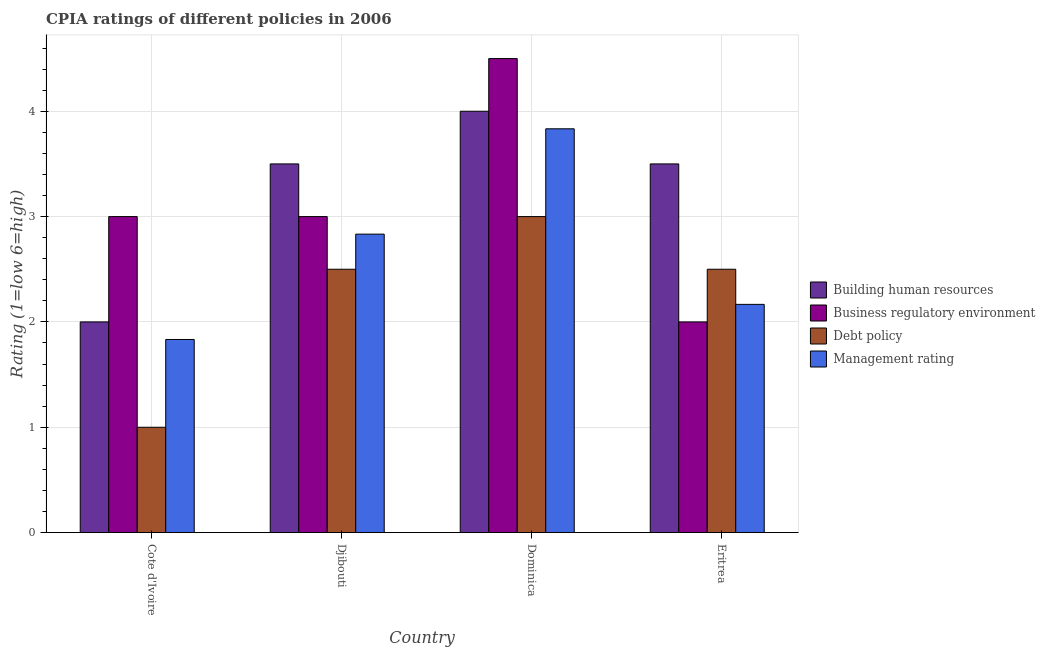How many bars are there on the 1st tick from the right?
Your answer should be compact. 4. What is the label of the 4th group of bars from the left?
Offer a terse response. Eritrea. What is the cpia rating of management in Dominica?
Give a very brief answer. 3.83. Across all countries, what is the maximum cpia rating of debt policy?
Keep it short and to the point. 3. Across all countries, what is the minimum cpia rating of building human resources?
Ensure brevity in your answer.  2. In which country was the cpia rating of building human resources maximum?
Your answer should be very brief. Dominica. In which country was the cpia rating of debt policy minimum?
Give a very brief answer. Cote d'Ivoire. What is the total cpia rating of debt policy in the graph?
Your answer should be very brief. 9. What is the difference between the cpia rating of building human resources in Djibouti and that in Dominica?
Make the answer very short. -0.5. What is the difference between the cpia rating of business regulatory environment in Cote d'Ivoire and the cpia rating of debt policy in Eritrea?
Provide a short and direct response. 0.5. What is the average cpia rating of building human resources per country?
Offer a terse response. 3.25. What is the difference between the cpia rating of business regulatory environment and cpia rating of management in Dominica?
Provide a short and direct response. 0.67. What is the ratio of the cpia rating of debt policy in Dominica to that in Eritrea?
Provide a succinct answer. 1.2. What is the difference between the highest and the second highest cpia rating of debt policy?
Offer a terse response. 0.5. What is the difference between the highest and the lowest cpia rating of debt policy?
Provide a short and direct response. 2. Is the sum of the cpia rating of building human resources in Djibouti and Dominica greater than the maximum cpia rating of debt policy across all countries?
Ensure brevity in your answer.  Yes. What does the 3rd bar from the left in Djibouti represents?
Provide a short and direct response. Debt policy. What does the 4th bar from the right in Dominica represents?
Offer a terse response. Building human resources. Is it the case that in every country, the sum of the cpia rating of building human resources and cpia rating of business regulatory environment is greater than the cpia rating of debt policy?
Keep it short and to the point. Yes. How many bars are there?
Your response must be concise. 16. Are all the bars in the graph horizontal?
Your answer should be very brief. No. Are the values on the major ticks of Y-axis written in scientific E-notation?
Make the answer very short. No. Does the graph contain any zero values?
Offer a very short reply. No. Where does the legend appear in the graph?
Provide a succinct answer. Center right. What is the title of the graph?
Your answer should be compact. CPIA ratings of different policies in 2006. Does "International Monetary Fund" appear as one of the legend labels in the graph?
Offer a very short reply. No. What is the label or title of the X-axis?
Offer a terse response. Country. What is the Rating (1=low 6=high) in Building human resources in Cote d'Ivoire?
Ensure brevity in your answer.  2. What is the Rating (1=low 6=high) in Business regulatory environment in Cote d'Ivoire?
Make the answer very short. 3. What is the Rating (1=low 6=high) of Debt policy in Cote d'Ivoire?
Offer a very short reply. 1. What is the Rating (1=low 6=high) of Management rating in Cote d'Ivoire?
Make the answer very short. 1.83. What is the Rating (1=low 6=high) in Building human resources in Djibouti?
Provide a succinct answer. 3.5. What is the Rating (1=low 6=high) in Management rating in Djibouti?
Provide a short and direct response. 2.83. What is the Rating (1=low 6=high) in Management rating in Dominica?
Make the answer very short. 3.83. What is the Rating (1=low 6=high) of Building human resources in Eritrea?
Give a very brief answer. 3.5. What is the Rating (1=low 6=high) in Debt policy in Eritrea?
Provide a succinct answer. 2.5. What is the Rating (1=low 6=high) of Management rating in Eritrea?
Keep it short and to the point. 2.17. Across all countries, what is the maximum Rating (1=low 6=high) in Business regulatory environment?
Keep it short and to the point. 4.5. Across all countries, what is the maximum Rating (1=low 6=high) in Management rating?
Offer a very short reply. 3.83. Across all countries, what is the minimum Rating (1=low 6=high) in Debt policy?
Your response must be concise. 1. Across all countries, what is the minimum Rating (1=low 6=high) in Management rating?
Your answer should be very brief. 1.83. What is the total Rating (1=low 6=high) in Building human resources in the graph?
Your answer should be compact. 13. What is the total Rating (1=low 6=high) of Business regulatory environment in the graph?
Offer a very short reply. 12.5. What is the total Rating (1=low 6=high) in Management rating in the graph?
Your answer should be compact. 10.67. What is the difference between the Rating (1=low 6=high) of Building human resources in Cote d'Ivoire and that in Djibouti?
Give a very brief answer. -1.5. What is the difference between the Rating (1=low 6=high) in Debt policy in Cote d'Ivoire and that in Djibouti?
Offer a very short reply. -1.5. What is the difference between the Rating (1=low 6=high) in Management rating in Cote d'Ivoire and that in Djibouti?
Ensure brevity in your answer.  -1. What is the difference between the Rating (1=low 6=high) in Business regulatory environment in Cote d'Ivoire and that in Dominica?
Your response must be concise. -1.5. What is the difference between the Rating (1=low 6=high) of Management rating in Cote d'Ivoire and that in Dominica?
Provide a succinct answer. -2. What is the difference between the Rating (1=low 6=high) of Building human resources in Cote d'Ivoire and that in Eritrea?
Make the answer very short. -1.5. What is the difference between the Rating (1=low 6=high) of Business regulatory environment in Cote d'Ivoire and that in Eritrea?
Provide a succinct answer. 1. What is the difference between the Rating (1=low 6=high) in Building human resources in Djibouti and that in Dominica?
Your answer should be compact. -0.5. What is the difference between the Rating (1=low 6=high) in Business regulatory environment in Djibouti and that in Dominica?
Your answer should be very brief. -1.5. What is the difference between the Rating (1=low 6=high) of Debt policy in Djibouti and that in Dominica?
Keep it short and to the point. -0.5. What is the difference between the Rating (1=low 6=high) of Management rating in Djibouti and that in Dominica?
Provide a succinct answer. -1. What is the difference between the Rating (1=low 6=high) of Building human resources in Djibouti and that in Eritrea?
Ensure brevity in your answer.  0. What is the difference between the Rating (1=low 6=high) of Business regulatory environment in Djibouti and that in Eritrea?
Your response must be concise. 1. What is the difference between the Rating (1=low 6=high) in Management rating in Dominica and that in Eritrea?
Provide a short and direct response. 1.67. What is the difference between the Rating (1=low 6=high) of Business regulatory environment in Cote d'Ivoire and the Rating (1=low 6=high) of Management rating in Djibouti?
Give a very brief answer. 0.17. What is the difference between the Rating (1=low 6=high) in Debt policy in Cote d'Ivoire and the Rating (1=low 6=high) in Management rating in Djibouti?
Make the answer very short. -1.83. What is the difference between the Rating (1=low 6=high) of Building human resources in Cote d'Ivoire and the Rating (1=low 6=high) of Debt policy in Dominica?
Make the answer very short. -1. What is the difference between the Rating (1=low 6=high) of Building human resources in Cote d'Ivoire and the Rating (1=low 6=high) of Management rating in Dominica?
Your response must be concise. -1.83. What is the difference between the Rating (1=low 6=high) of Business regulatory environment in Cote d'Ivoire and the Rating (1=low 6=high) of Debt policy in Dominica?
Make the answer very short. 0. What is the difference between the Rating (1=low 6=high) in Debt policy in Cote d'Ivoire and the Rating (1=low 6=high) in Management rating in Dominica?
Ensure brevity in your answer.  -2.83. What is the difference between the Rating (1=low 6=high) in Debt policy in Cote d'Ivoire and the Rating (1=low 6=high) in Management rating in Eritrea?
Offer a terse response. -1.17. What is the difference between the Rating (1=low 6=high) in Building human resources in Djibouti and the Rating (1=low 6=high) in Business regulatory environment in Dominica?
Your answer should be compact. -1. What is the difference between the Rating (1=low 6=high) in Debt policy in Djibouti and the Rating (1=low 6=high) in Management rating in Dominica?
Provide a succinct answer. -1.33. What is the difference between the Rating (1=low 6=high) in Building human resources in Djibouti and the Rating (1=low 6=high) in Business regulatory environment in Eritrea?
Offer a very short reply. 1.5. What is the difference between the Rating (1=low 6=high) in Building human resources in Djibouti and the Rating (1=low 6=high) in Debt policy in Eritrea?
Your answer should be very brief. 1. What is the difference between the Rating (1=low 6=high) of Building human resources in Djibouti and the Rating (1=low 6=high) of Management rating in Eritrea?
Offer a very short reply. 1.33. What is the difference between the Rating (1=low 6=high) in Debt policy in Djibouti and the Rating (1=low 6=high) in Management rating in Eritrea?
Offer a terse response. 0.33. What is the difference between the Rating (1=low 6=high) in Building human resources in Dominica and the Rating (1=low 6=high) in Debt policy in Eritrea?
Offer a terse response. 1.5. What is the difference between the Rating (1=low 6=high) of Building human resources in Dominica and the Rating (1=low 6=high) of Management rating in Eritrea?
Offer a terse response. 1.83. What is the difference between the Rating (1=low 6=high) of Business regulatory environment in Dominica and the Rating (1=low 6=high) of Management rating in Eritrea?
Offer a terse response. 2.33. What is the average Rating (1=low 6=high) of Business regulatory environment per country?
Provide a short and direct response. 3.12. What is the average Rating (1=low 6=high) of Debt policy per country?
Your answer should be compact. 2.25. What is the average Rating (1=low 6=high) of Management rating per country?
Your response must be concise. 2.67. What is the difference between the Rating (1=low 6=high) in Building human resources and Rating (1=low 6=high) in Debt policy in Cote d'Ivoire?
Offer a very short reply. 1. What is the difference between the Rating (1=low 6=high) in Building human resources and Rating (1=low 6=high) in Management rating in Cote d'Ivoire?
Your response must be concise. 0.17. What is the difference between the Rating (1=low 6=high) of Business regulatory environment and Rating (1=low 6=high) of Management rating in Cote d'Ivoire?
Your answer should be very brief. 1.17. What is the difference between the Rating (1=low 6=high) in Building human resources and Rating (1=low 6=high) in Business regulatory environment in Djibouti?
Give a very brief answer. 0.5. What is the difference between the Rating (1=low 6=high) in Building human resources and Rating (1=low 6=high) in Debt policy in Djibouti?
Give a very brief answer. 1. What is the difference between the Rating (1=low 6=high) of Business regulatory environment and Rating (1=low 6=high) of Management rating in Djibouti?
Keep it short and to the point. 0.17. What is the difference between the Rating (1=low 6=high) in Building human resources and Rating (1=low 6=high) in Debt policy in Dominica?
Provide a short and direct response. 1. What is the difference between the Rating (1=low 6=high) of Building human resources and Rating (1=low 6=high) of Management rating in Dominica?
Offer a terse response. 0.17. What is the difference between the Rating (1=low 6=high) of Business regulatory environment and Rating (1=low 6=high) of Management rating in Dominica?
Provide a succinct answer. 0.67. What is the difference between the Rating (1=low 6=high) in Debt policy and Rating (1=low 6=high) in Management rating in Dominica?
Provide a short and direct response. -0.83. What is the difference between the Rating (1=low 6=high) in Building human resources and Rating (1=low 6=high) in Debt policy in Eritrea?
Offer a very short reply. 1. What is the difference between the Rating (1=low 6=high) of Building human resources and Rating (1=low 6=high) of Management rating in Eritrea?
Your response must be concise. 1.33. What is the difference between the Rating (1=low 6=high) of Business regulatory environment and Rating (1=low 6=high) of Debt policy in Eritrea?
Your answer should be very brief. -0.5. What is the difference between the Rating (1=low 6=high) of Debt policy and Rating (1=low 6=high) of Management rating in Eritrea?
Give a very brief answer. 0.33. What is the ratio of the Rating (1=low 6=high) in Management rating in Cote d'Ivoire to that in Djibouti?
Offer a very short reply. 0.65. What is the ratio of the Rating (1=low 6=high) in Building human resources in Cote d'Ivoire to that in Dominica?
Make the answer very short. 0.5. What is the ratio of the Rating (1=low 6=high) in Business regulatory environment in Cote d'Ivoire to that in Dominica?
Your answer should be very brief. 0.67. What is the ratio of the Rating (1=low 6=high) of Debt policy in Cote d'Ivoire to that in Dominica?
Your response must be concise. 0.33. What is the ratio of the Rating (1=low 6=high) in Management rating in Cote d'Ivoire to that in Dominica?
Ensure brevity in your answer.  0.48. What is the ratio of the Rating (1=low 6=high) in Debt policy in Cote d'Ivoire to that in Eritrea?
Keep it short and to the point. 0.4. What is the ratio of the Rating (1=low 6=high) of Management rating in Cote d'Ivoire to that in Eritrea?
Your answer should be very brief. 0.85. What is the ratio of the Rating (1=low 6=high) in Debt policy in Djibouti to that in Dominica?
Provide a succinct answer. 0.83. What is the ratio of the Rating (1=low 6=high) in Management rating in Djibouti to that in Dominica?
Your response must be concise. 0.74. What is the ratio of the Rating (1=low 6=high) of Building human resources in Djibouti to that in Eritrea?
Provide a short and direct response. 1. What is the ratio of the Rating (1=low 6=high) in Debt policy in Djibouti to that in Eritrea?
Provide a succinct answer. 1. What is the ratio of the Rating (1=low 6=high) in Management rating in Djibouti to that in Eritrea?
Provide a succinct answer. 1.31. What is the ratio of the Rating (1=low 6=high) of Building human resources in Dominica to that in Eritrea?
Your answer should be compact. 1.14. What is the ratio of the Rating (1=low 6=high) in Business regulatory environment in Dominica to that in Eritrea?
Provide a succinct answer. 2.25. What is the ratio of the Rating (1=low 6=high) of Management rating in Dominica to that in Eritrea?
Make the answer very short. 1.77. What is the difference between the highest and the second highest Rating (1=low 6=high) of Management rating?
Make the answer very short. 1. What is the difference between the highest and the lowest Rating (1=low 6=high) in Debt policy?
Your response must be concise. 2. 